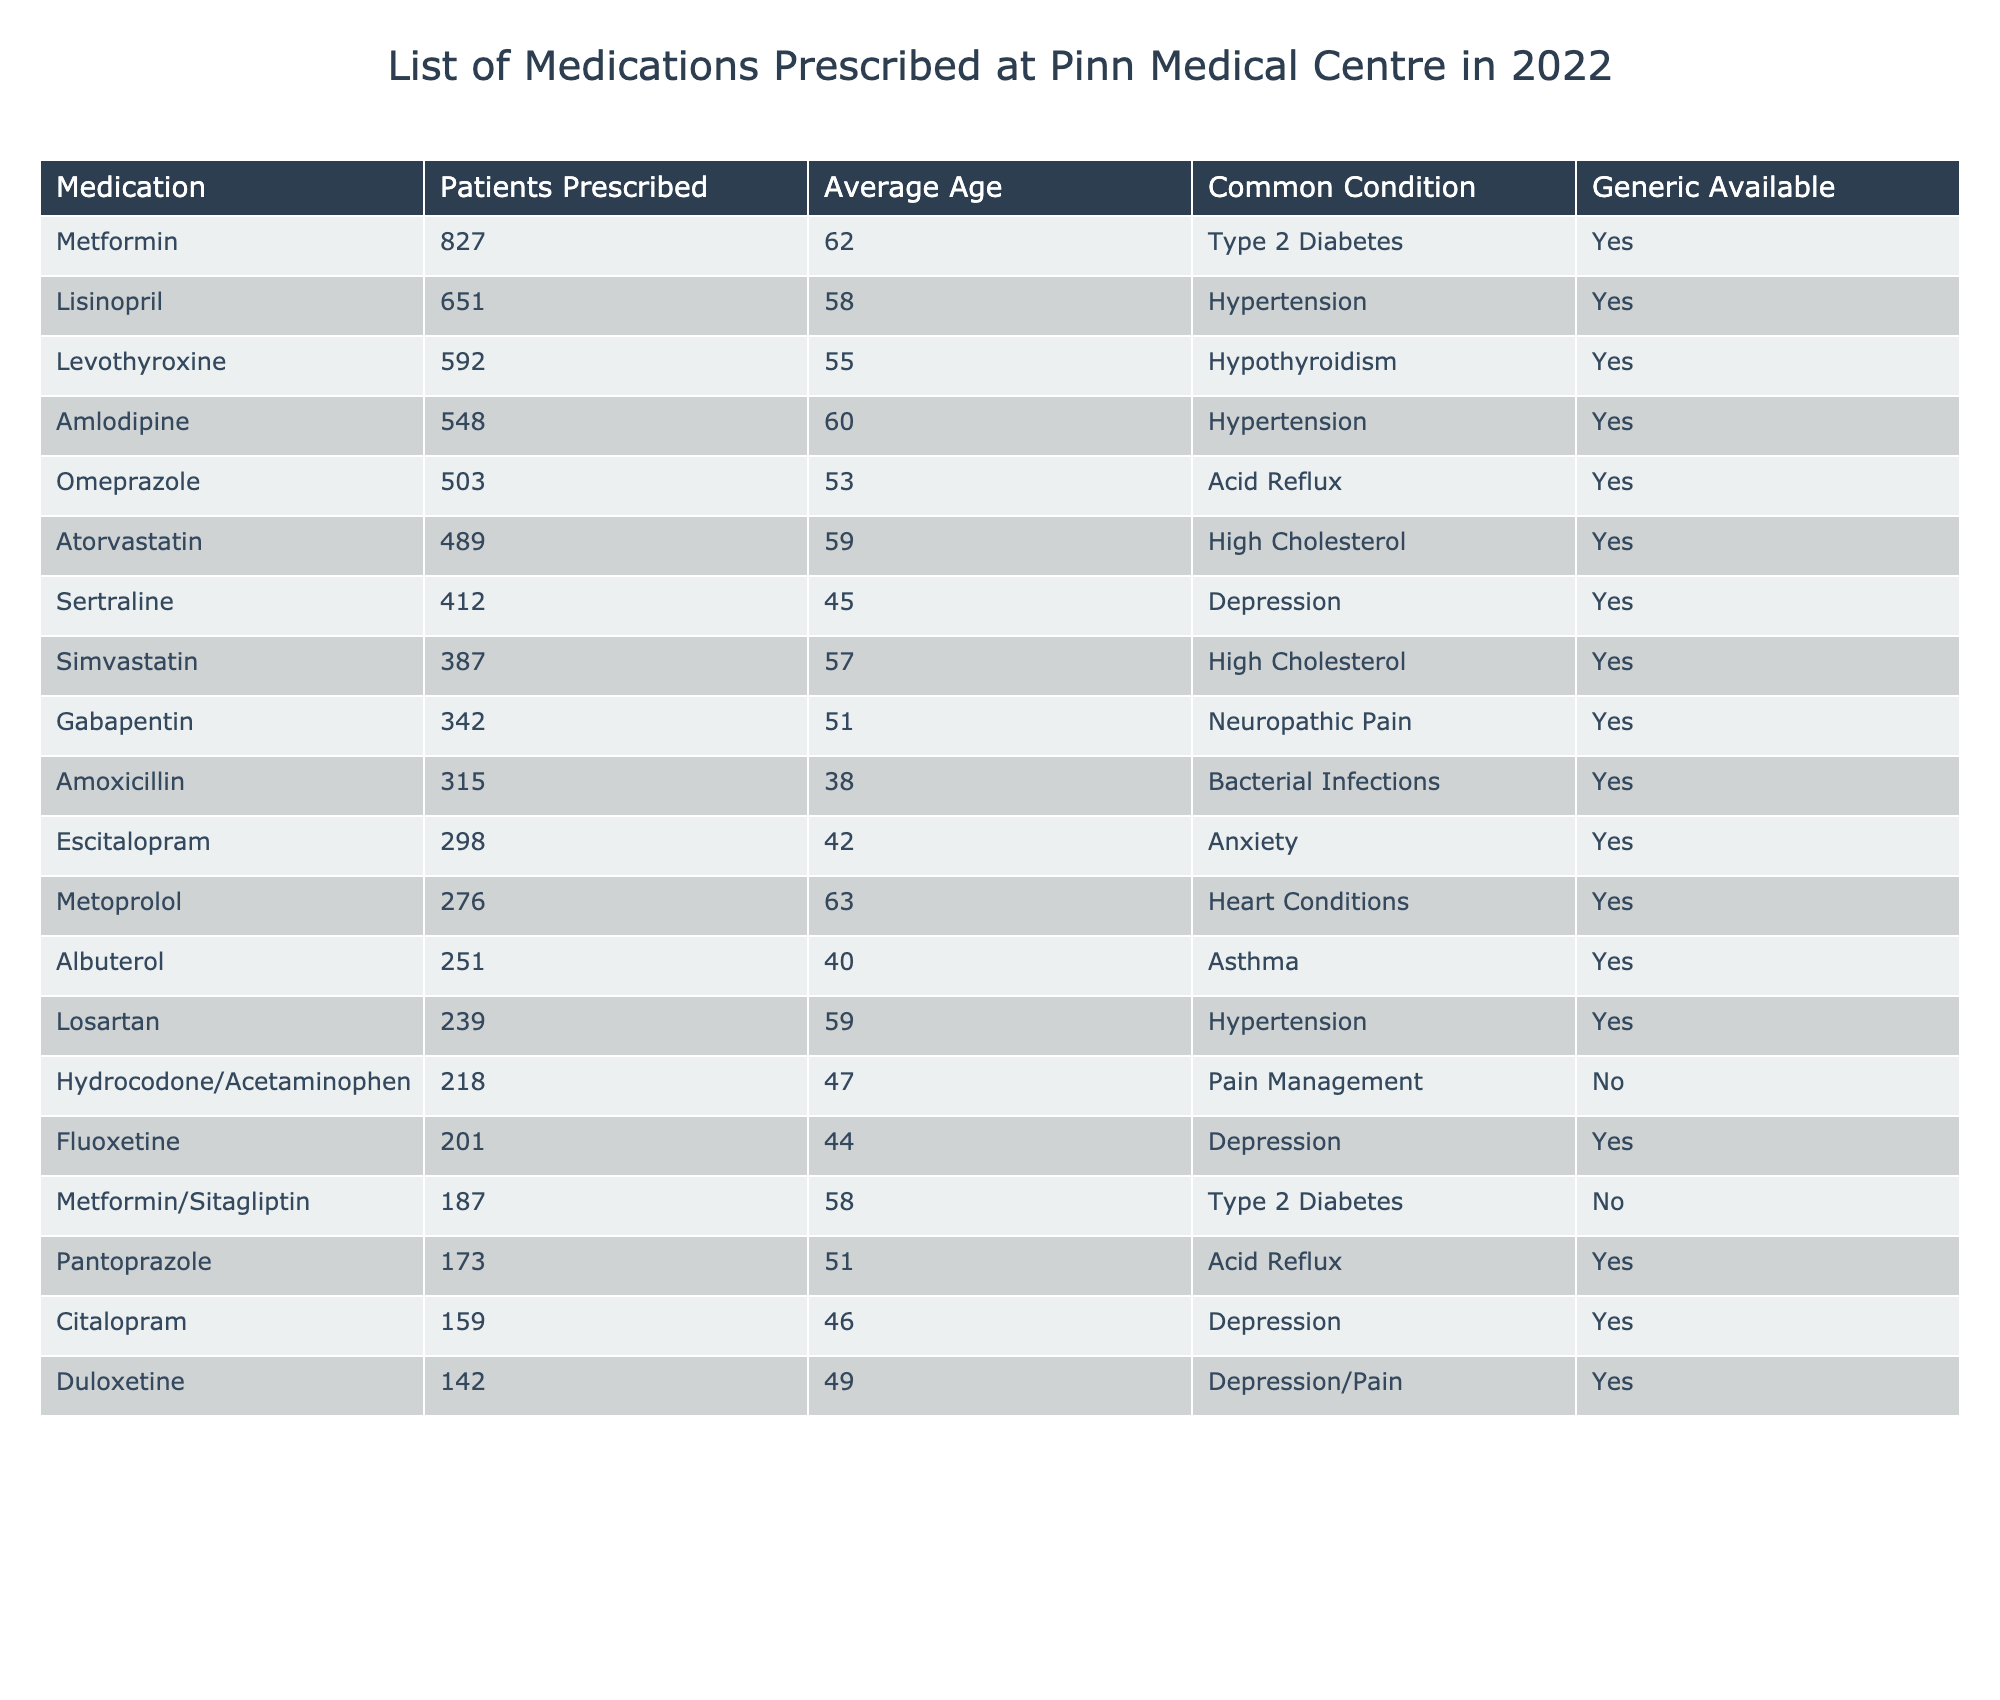What medication was prescribed to the highest number of patients? The table shows the number of patients prescribed each medication. By comparing the "Patients Prescribed" column, Metformin has the highest value of 827.
Answer: 827 What is the average age of patients prescribed Lisinopril? The table lists Lisinopril with an average age of 58 years in the "Average Age" column.
Answer: 58 Which medication is commonly prescribed for Type 2 Diabetes? Metformin and Metformin/Sitagliptin are indicated for Type 2 Diabetes in the "Common Condition" column. Among these, Metformin has more patients prescribed.
Answer: Metformin How many patients were prescribed Duloxetine? The column for "Patients Prescribed" shows that 142 patients were prescribed Duloxetine.
Answer: 142 What is the average age of patients prescribed Sertraline? The average age for patients prescribed Sertraline is listed as 45 in the "Average Age" column.
Answer: 45 Is there a generic available for Hydrocodone/Acetaminophen? The "Generic Available" column indicates that for Hydrocodone/Acetaminophen, no generic is available.
Answer: No Which medication has the lowest number of patients prescribed and what is that number? The table indicates that Duloxetine has 142 patients prescribed, which is the lowest when comparing all medications.
Answer: 142 What condition is commonly treated with Amlodipine? The table specifies that Amlodipine is used for Hypertension as shown in the "Common Condition" column.
Answer: Hypertension Calculate the total number of patients prescribed the top three medications. The top three medications are Metformin (827), Lisinopril (651), and Levothyroxine (592). Adding these together gives 827 + 651 + 592 = 2070.
Answer: 2070 What proportion of the patients prescribed medications for Depression are prescribed Sertraline? There are 412 patients prescribed Sertraline out of 201 (Fluoxetine) + 412 (Sertraline) + 159 (Citalopram) + 142 (Duloxetine) = 912 total. The proportion is calculated as 412/912 ≈ 0.452 or 45.2%.
Answer: Approximately 45.2% 